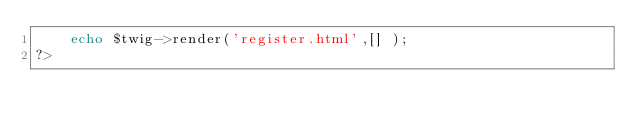<code> <loc_0><loc_0><loc_500><loc_500><_PHP_>    echo $twig->render('register.html',[] );
?>
</code> 